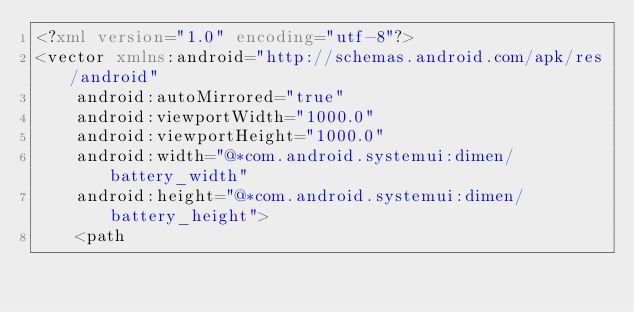Convert code to text. <code><loc_0><loc_0><loc_500><loc_500><_XML_><?xml version="1.0" encoding="utf-8"?>
<vector xmlns:android="http://schemas.android.com/apk/res/android"
    android:autoMirrored="true" 
    android:viewportWidth="1000.0"
    android:viewportHeight="1000.0"
    android:width="@*com.android.systemui:dimen/battery_width"
    android:height="@*com.android.systemui:dimen/battery_height">
    <path</code> 